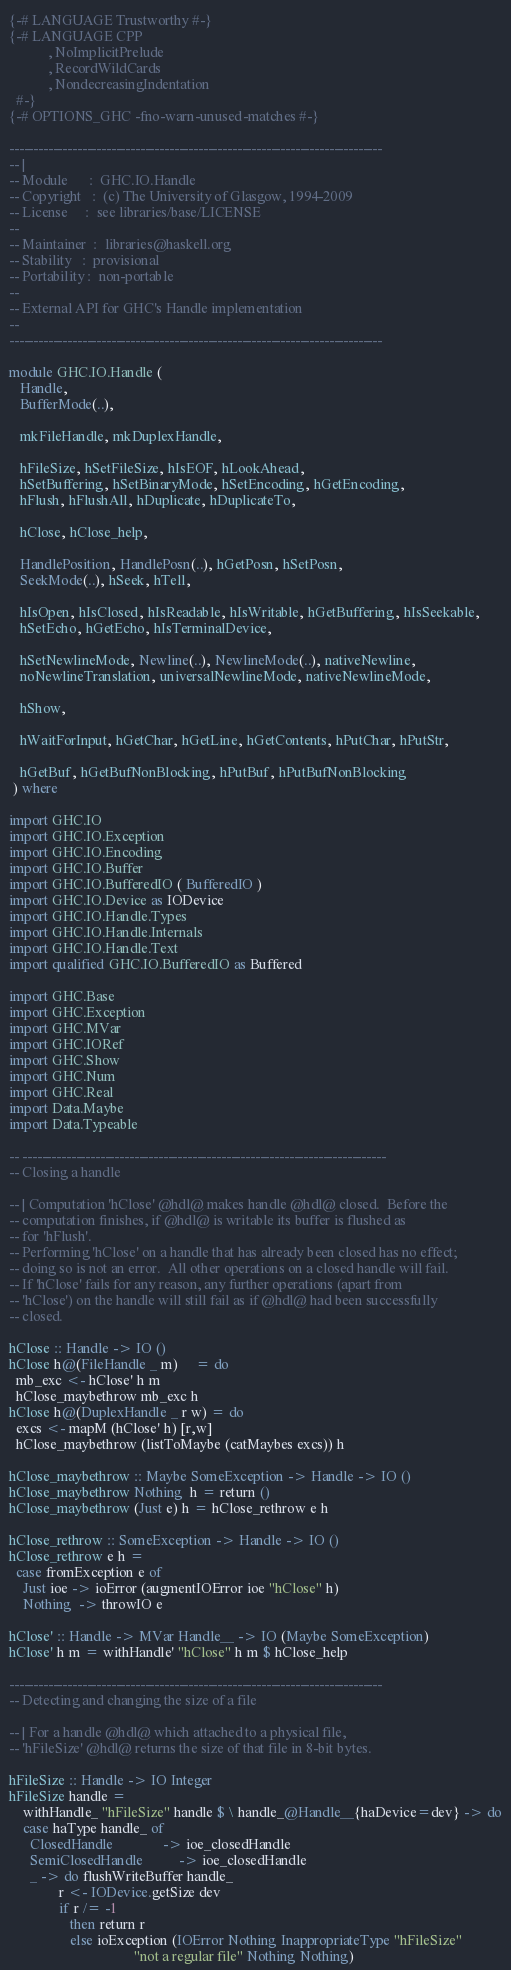Convert code to text. <code><loc_0><loc_0><loc_500><loc_500><_Haskell_>{-# LANGUAGE Trustworthy #-}
{-# LANGUAGE CPP
           , NoImplicitPrelude
           , RecordWildCards
           , NondecreasingIndentation
  #-}
{-# OPTIONS_GHC -fno-warn-unused-matches #-}

-----------------------------------------------------------------------------
-- |
-- Module      :  GHC.IO.Handle
-- Copyright   :  (c) The University of Glasgow, 1994-2009
-- License     :  see libraries/base/LICENSE
--
-- Maintainer  :  libraries@haskell.org
-- Stability   :  provisional
-- Portability :  non-portable
--
-- External API for GHC's Handle implementation
--
-----------------------------------------------------------------------------

module GHC.IO.Handle (
   Handle,
   BufferMode(..),

   mkFileHandle, mkDuplexHandle,

   hFileSize, hSetFileSize, hIsEOF, hLookAhead,
   hSetBuffering, hSetBinaryMode, hSetEncoding, hGetEncoding,
   hFlush, hFlushAll, hDuplicate, hDuplicateTo,

   hClose, hClose_help,

   HandlePosition, HandlePosn(..), hGetPosn, hSetPosn,
   SeekMode(..), hSeek, hTell,

   hIsOpen, hIsClosed, hIsReadable, hIsWritable, hGetBuffering, hIsSeekable,
   hSetEcho, hGetEcho, hIsTerminalDevice,

   hSetNewlineMode, Newline(..), NewlineMode(..), nativeNewline,
   noNewlineTranslation, universalNewlineMode, nativeNewlineMode,

   hShow,

   hWaitForInput, hGetChar, hGetLine, hGetContents, hPutChar, hPutStr,

   hGetBuf, hGetBufNonBlocking, hPutBuf, hPutBufNonBlocking
 ) where

import GHC.IO
import GHC.IO.Exception
import GHC.IO.Encoding
import GHC.IO.Buffer
import GHC.IO.BufferedIO ( BufferedIO )
import GHC.IO.Device as IODevice
import GHC.IO.Handle.Types
import GHC.IO.Handle.Internals
import GHC.IO.Handle.Text
import qualified GHC.IO.BufferedIO as Buffered

import GHC.Base
import GHC.Exception
import GHC.MVar
import GHC.IORef
import GHC.Show
import GHC.Num
import GHC.Real
import Data.Maybe
import Data.Typeable

-- ---------------------------------------------------------------------------
-- Closing a handle

-- | Computation 'hClose' @hdl@ makes handle @hdl@ closed.  Before the
-- computation finishes, if @hdl@ is writable its buffer is flushed as
-- for 'hFlush'.
-- Performing 'hClose' on a handle that has already been closed has no effect;
-- doing so is not an error.  All other operations on a closed handle will fail.
-- If 'hClose' fails for any reason, any further operations (apart from
-- 'hClose') on the handle will still fail as if @hdl@ had been successfully
-- closed.

hClose :: Handle -> IO ()
hClose h@(FileHandle _ m)     = do
  mb_exc <- hClose' h m
  hClose_maybethrow mb_exc h
hClose h@(DuplexHandle _ r w) = do
  excs <- mapM (hClose' h) [r,w]
  hClose_maybethrow (listToMaybe (catMaybes excs)) h

hClose_maybethrow :: Maybe SomeException -> Handle -> IO ()
hClose_maybethrow Nothing  h = return ()
hClose_maybethrow (Just e) h = hClose_rethrow e h

hClose_rethrow :: SomeException -> Handle -> IO ()
hClose_rethrow e h =
  case fromException e of
    Just ioe -> ioError (augmentIOError ioe "hClose" h)
    Nothing  -> throwIO e

hClose' :: Handle -> MVar Handle__ -> IO (Maybe SomeException)
hClose' h m = withHandle' "hClose" h m $ hClose_help

-----------------------------------------------------------------------------
-- Detecting and changing the size of a file

-- | For a handle @hdl@ which attached to a physical file,
-- 'hFileSize' @hdl@ returns the size of that file in 8-bit bytes.

hFileSize :: Handle -> IO Integer
hFileSize handle =
    withHandle_ "hFileSize" handle $ \ handle_@Handle__{haDevice=dev} -> do
    case haType handle_ of
      ClosedHandle              -> ioe_closedHandle
      SemiClosedHandle          -> ioe_closedHandle
      _ -> do flushWriteBuffer handle_
              r <- IODevice.getSize dev
              if r /= -1
                 then return r
                 else ioException (IOError Nothing InappropriateType "hFileSize"
                                   "not a regular file" Nothing Nothing)

</code> 